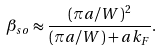<formula> <loc_0><loc_0><loc_500><loc_500>\beta _ { s o } \approx \frac { ( \pi a / W ) ^ { 2 } } { ( \pi a / W ) + a k _ { F } } .</formula> 